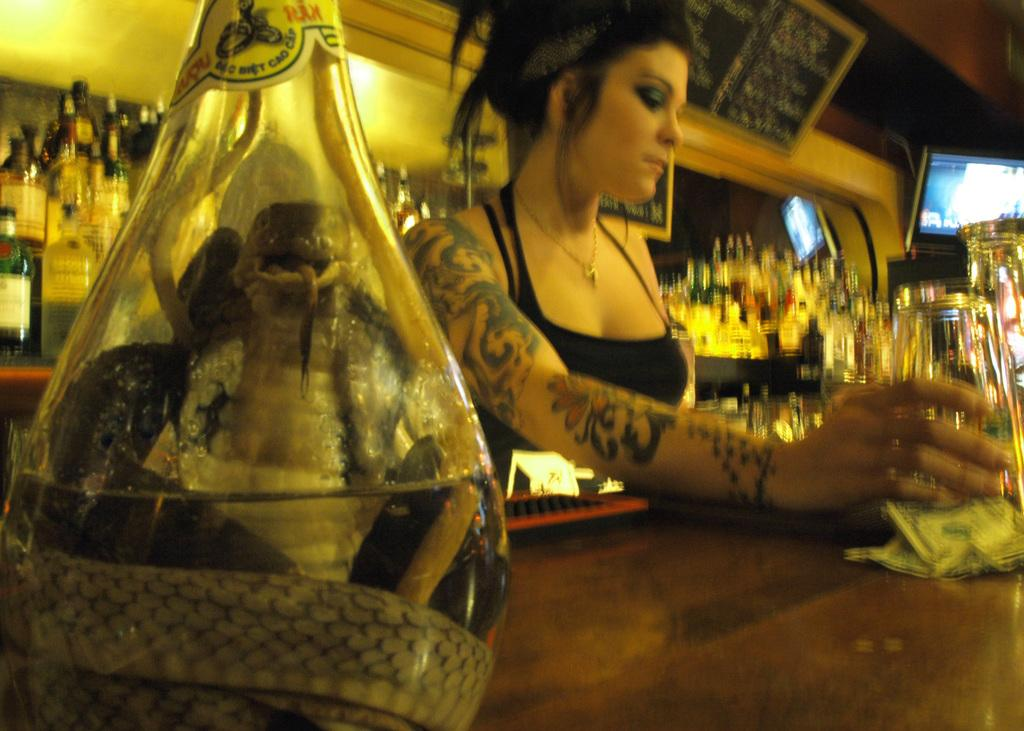Who is present in the image? There is a woman in the image. What is the woman holding in the image? The woman is holding a glass. What unusual object can be seen in the image? There is a snake in a flask in the image. How many bottles are visible in the image? There are multiple bottles visible in the image. What type of body art does the woman have? The woman has a tattoo on her hand. What type of bomb is the woman attempting to disarm in the image? There is no bomb present in the image; it features a woman holding a glass, a snake in a flask, and multiple bottles. What cause does the woman support, as indicated by her tattoo in the image? The tattoo on the woman's hand does not indicate any specific cause or affiliation. 